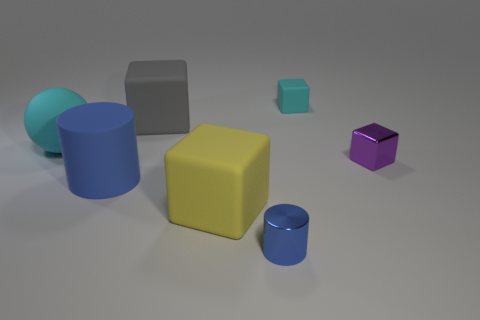Add 3 blue shiny objects. How many objects exist? 10 Subtract 1 blocks. How many blocks are left? 3 Subtract all big gray cubes. How many cubes are left? 3 Subtract all purple blocks. How many blocks are left? 3 Subtract 0 red spheres. How many objects are left? 7 Subtract all cubes. How many objects are left? 3 Subtract all brown blocks. Subtract all yellow balls. How many blocks are left? 4 Subtract all yellow spheres. How many green cylinders are left? 0 Subtract all big blue rubber cylinders. Subtract all big brown metal cylinders. How many objects are left? 6 Add 7 yellow blocks. How many yellow blocks are left? 8 